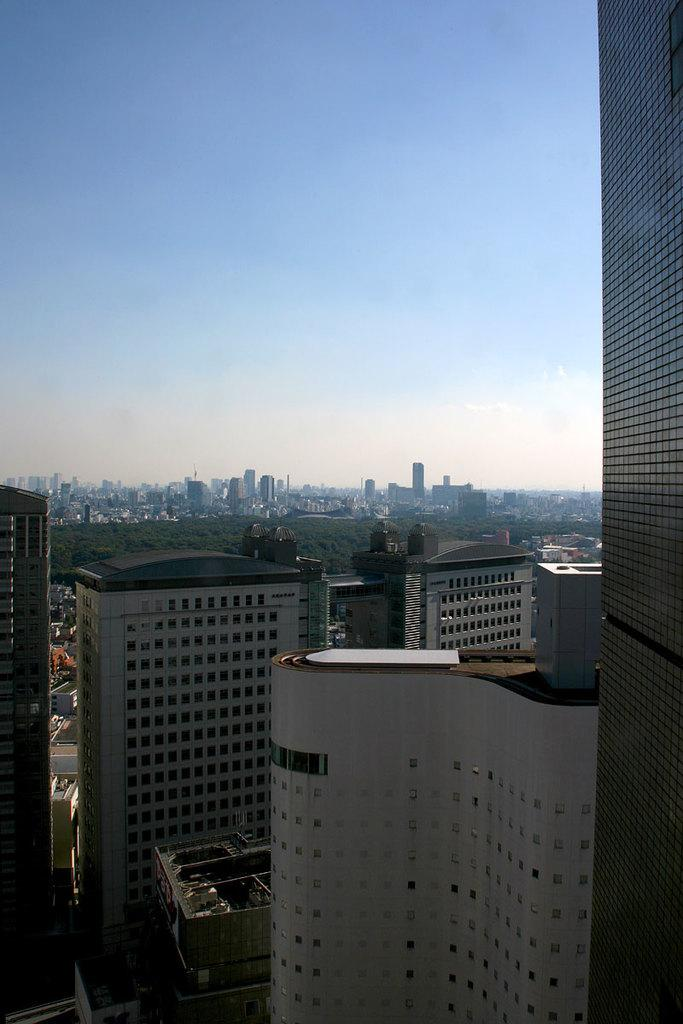What is located at the bottom of the image? There are buildings and mountains at the bottom of the image. Can you describe the position of the mountains in relation to the ground? The mountains are on the ground at the bottom of the image. What can be seen in the sky in the background of the image? There are clouds in the sky in the background of the image. What type of letter is the toad holding in the image? There is no toad or letter present in the image. Can you tell me what kind of guitar is being played in the image? There is no guitar or music-related activity depicted in the image. 